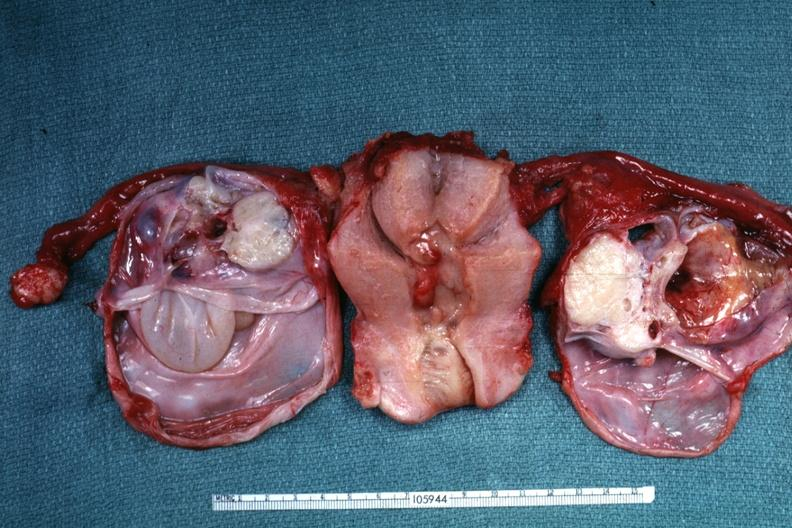s serous cystadenoma present?
Answer the question using a single word or phrase. Yes 